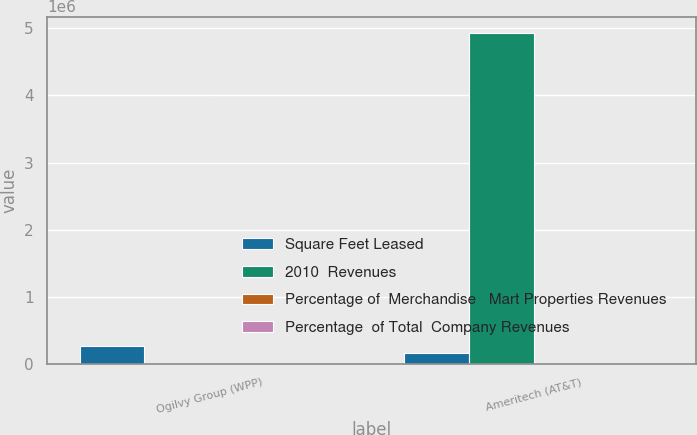Convert chart. <chart><loc_0><loc_0><loc_500><loc_500><stacked_bar_chart><ecel><fcel>Ogilvy Group (WPP)<fcel>Ameritech (AT&T)<nl><fcel>Square Feet Leased<fcel>270000<fcel>171000<nl><fcel>2010  Revenues<fcel>3.1<fcel>4.924e+06<nl><fcel>Percentage of  Merchandise   Mart Properties Revenues<fcel>3.1<fcel>2<nl><fcel>Percentage  of Total  Company Revenues<fcel>0.3<fcel>0.2<nl></chart> 